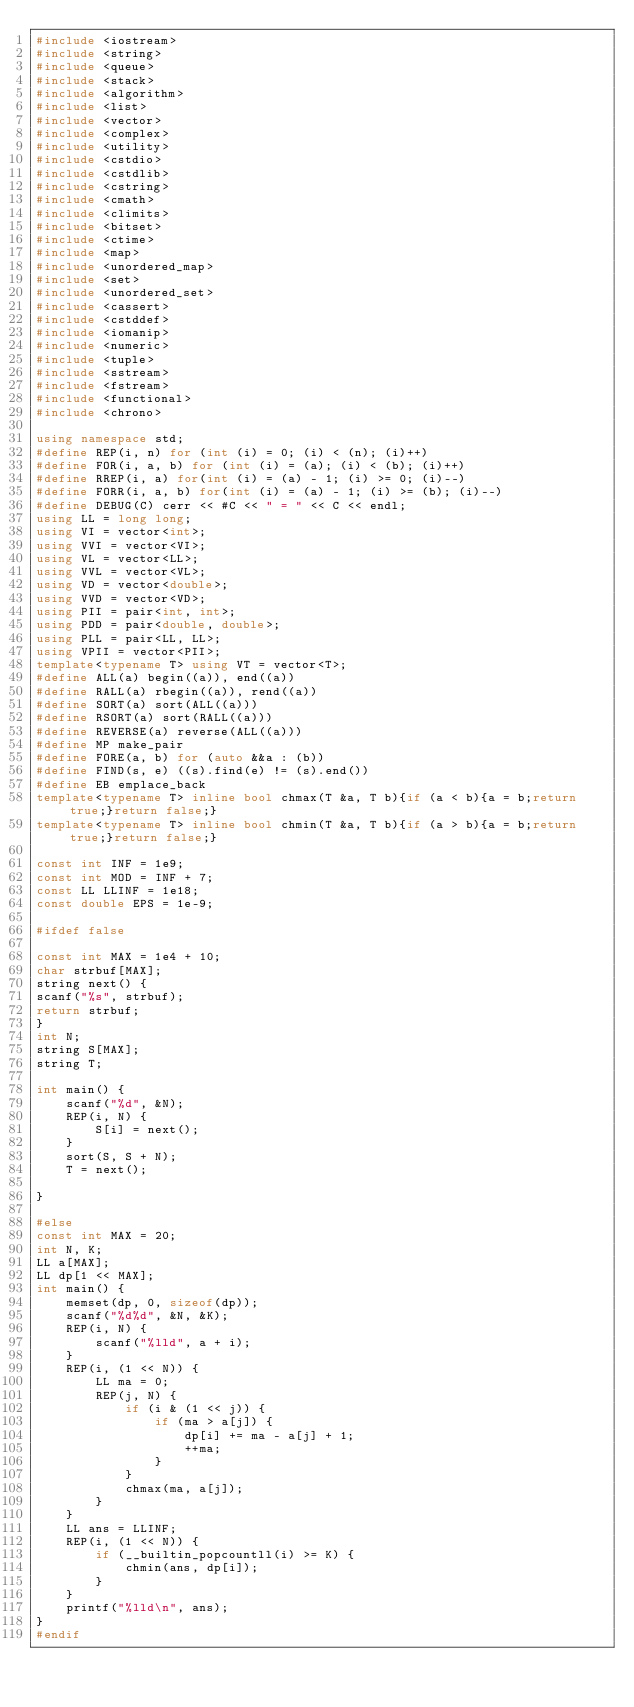Convert code to text. <code><loc_0><loc_0><loc_500><loc_500><_C++_>#include <iostream>
#include <string>
#include <queue>
#include <stack>
#include <algorithm>
#include <list>
#include <vector>
#include <complex>
#include <utility>
#include <cstdio>
#include <cstdlib>
#include <cstring>
#include <cmath>
#include <climits>
#include <bitset>
#include <ctime>
#include <map>
#include <unordered_map>
#include <set>
#include <unordered_set>
#include <cassert>
#include <cstddef>
#include <iomanip>
#include <numeric>
#include <tuple>
#include <sstream>
#include <fstream>
#include <functional>
#include <chrono>

using namespace std;
#define REP(i, n) for (int (i) = 0; (i) < (n); (i)++)
#define FOR(i, a, b) for (int (i) = (a); (i) < (b); (i)++)
#define RREP(i, a) for(int (i) = (a) - 1; (i) >= 0; (i)--)
#define FORR(i, a, b) for(int (i) = (a) - 1; (i) >= (b); (i)--)
#define DEBUG(C) cerr << #C << " = " << C << endl;
using LL = long long;
using VI = vector<int>;
using VVI = vector<VI>;
using VL = vector<LL>;
using VVL = vector<VL>;
using VD = vector<double>;
using VVD = vector<VD>;
using PII = pair<int, int>;
using PDD = pair<double, double>;
using PLL = pair<LL, LL>;
using VPII = vector<PII>;
template<typename T> using VT = vector<T>;
#define ALL(a) begin((a)), end((a))
#define RALL(a) rbegin((a)), rend((a))
#define SORT(a) sort(ALL((a)))
#define RSORT(a) sort(RALL((a)))
#define REVERSE(a) reverse(ALL((a)))
#define MP make_pair
#define FORE(a, b) for (auto &&a : (b))
#define FIND(s, e) ((s).find(e) != (s).end())
#define EB emplace_back
template<typename T> inline bool chmax(T &a, T b){if (a < b){a = b;return true;}return false;}
template<typename T> inline bool chmin(T &a, T b){if (a > b){a = b;return true;}return false;}

const int INF = 1e9;
const int MOD = INF + 7;
const LL LLINF = 1e18;
const double EPS = 1e-9;

#ifdef false

const int MAX = 1e4 + 10;
char strbuf[MAX];
string next() {
scanf("%s", strbuf);
return strbuf;
}
int N;
string S[MAX];
string T;

int main() {
    scanf("%d", &N);
    REP(i, N) {
        S[i] = next();
    }
    sort(S, S + N);
    T = next();

}

#else
const int MAX = 20;
int N, K;
LL a[MAX];
LL dp[1 << MAX];
int main() {
    memset(dp, 0, sizeof(dp));
    scanf("%d%d", &N, &K);
    REP(i, N) {
        scanf("%lld", a + i);
    }
    REP(i, (1 << N)) {
        LL ma = 0;
        REP(j, N) {
            if (i & (1 << j)) {
                if (ma > a[j]) {
                    dp[i] += ma - a[j] + 1;
                    ++ma;
                }
            }
            chmax(ma, a[j]);
        }
    }
    LL ans = LLINF;
    REP(i, (1 << N)) {
        if (__builtin_popcountll(i) >= K) {
            chmin(ans, dp[i]);
        }
    }
    printf("%lld\n", ans);
}
#endif
</code> 